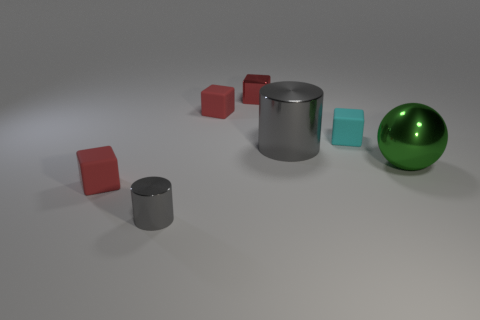Is the color of the large cylinder the same as the tiny cylinder?
Offer a very short reply. Yes. What size is the other metallic cylinder that is the same color as the big cylinder?
Keep it short and to the point. Small. There is a cylinder left of the red matte block that is behind the green sphere; what is its material?
Keep it short and to the point. Metal. The metal thing that is behind the green object and in front of the cyan cube has what shape?
Ensure brevity in your answer.  Cylinder. What size is the other shiny object that is the same shape as the tiny cyan thing?
Provide a short and direct response. Small. Is the number of big gray cylinders to the right of the big green metal thing less than the number of red matte cubes?
Provide a succinct answer. Yes. There is a gray cylinder to the right of the shiny block; what size is it?
Your response must be concise. Large. What is the color of the other small metallic thing that is the same shape as the tiny cyan thing?
Keep it short and to the point. Red. What number of tiny objects are the same color as the big metallic cylinder?
Provide a succinct answer. 1. Is there any other thing that has the same shape as the green object?
Provide a short and direct response. No. 